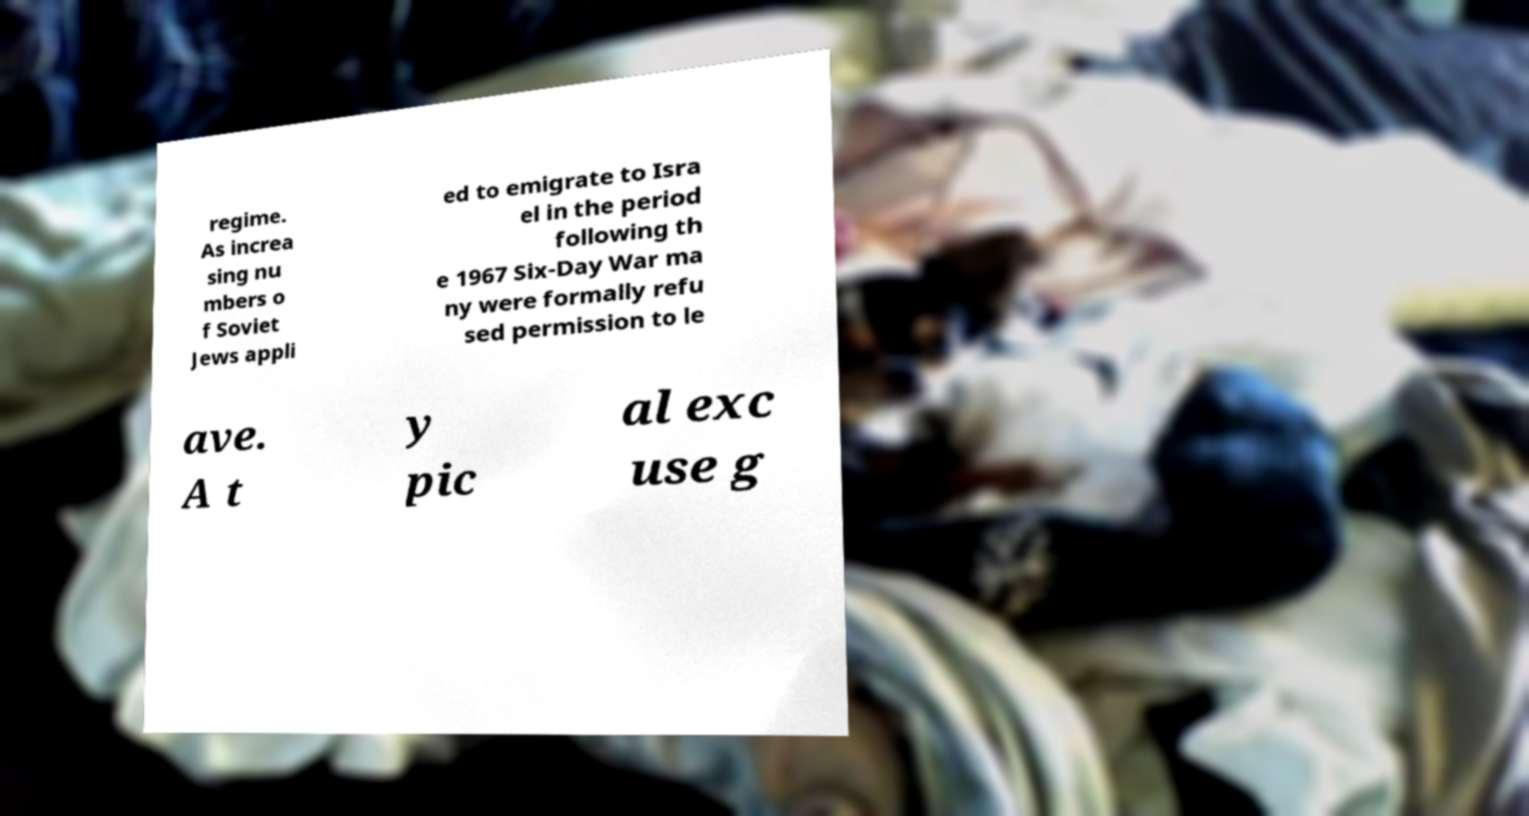Could you assist in decoding the text presented in this image and type it out clearly? regime. As increa sing nu mbers o f Soviet Jews appli ed to emigrate to Isra el in the period following th e 1967 Six-Day War ma ny were formally refu sed permission to le ave. A t y pic al exc use g 